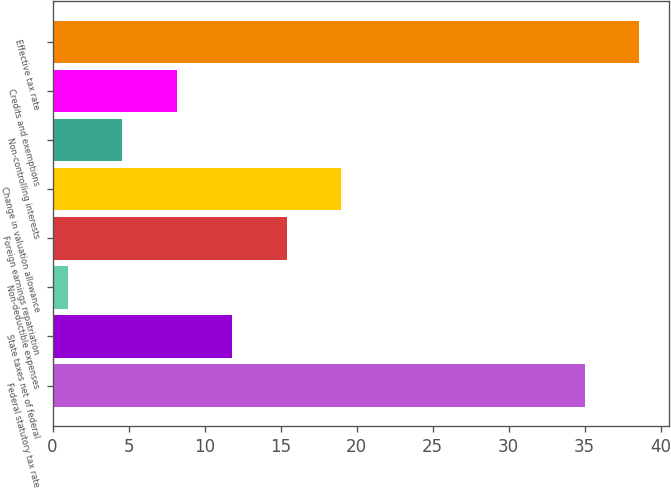Convert chart to OTSL. <chart><loc_0><loc_0><loc_500><loc_500><bar_chart><fcel>Federal statutory tax rate<fcel>State taxes net of federal<fcel>Non-deductible expenses<fcel>Foreign earnings repatriation<fcel>Change in valuation allowance<fcel>Non-controlling interests<fcel>Credits and exemptions<fcel>Effective tax rate<nl><fcel>35<fcel>11.8<fcel>1<fcel>15.4<fcel>19<fcel>4.6<fcel>8.2<fcel>38.6<nl></chart> 